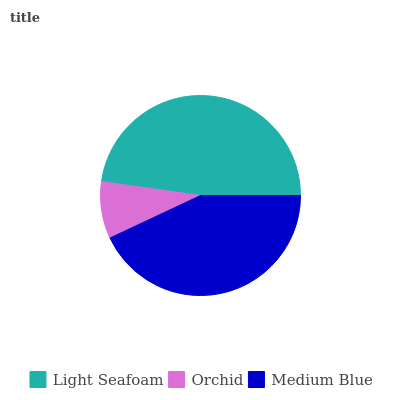Is Orchid the minimum?
Answer yes or no. Yes. Is Light Seafoam the maximum?
Answer yes or no. Yes. Is Medium Blue the minimum?
Answer yes or no. No. Is Medium Blue the maximum?
Answer yes or no. No. Is Medium Blue greater than Orchid?
Answer yes or no. Yes. Is Orchid less than Medium Blue?
Answer yes or no. Yes. Is Orchid greater than Medium Blue?
Answer yes or no. No. Is Medium Blue less than Orchid?
Answer yes or no. No. Is Medium Blue the high median?
Answer yes or no. Yes. Is Medium Blue the low median?
Answer yes or no. Yes. Is Orchid the high median?
Answer yes or no. No. Is Orchid the low median?
Answer yes or no. No. 